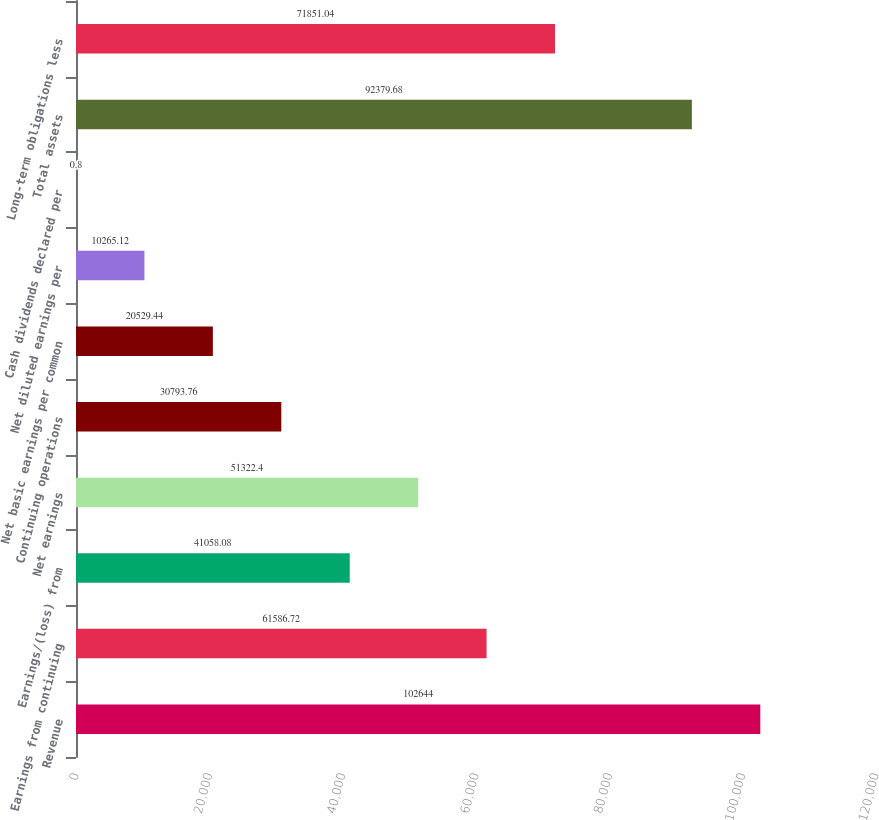Convert chart. <chart><loc_0><loc_0><loc_500><loc_500><bar_chart><fcel>Revenue<fcel>Earnings from continuing<fcel>Earnings/(loss) from<fcel>Net earnings<fcel>Continuing operations<fcel>Net basic earnings per common<fcel>Net diluted earnings per<fcel>Cash dividends declared per<fcel>Total assets<fcel>Long-term obligations less<nl><fcel>102644<fcel>61586.7<fcel>41058.1<fcel>51322.4<fcel>30793.8<fcel>20529.4<fcel>10265.1<fcel>0.8<fcel>92379.7<fcel>71851<nl></chart> 